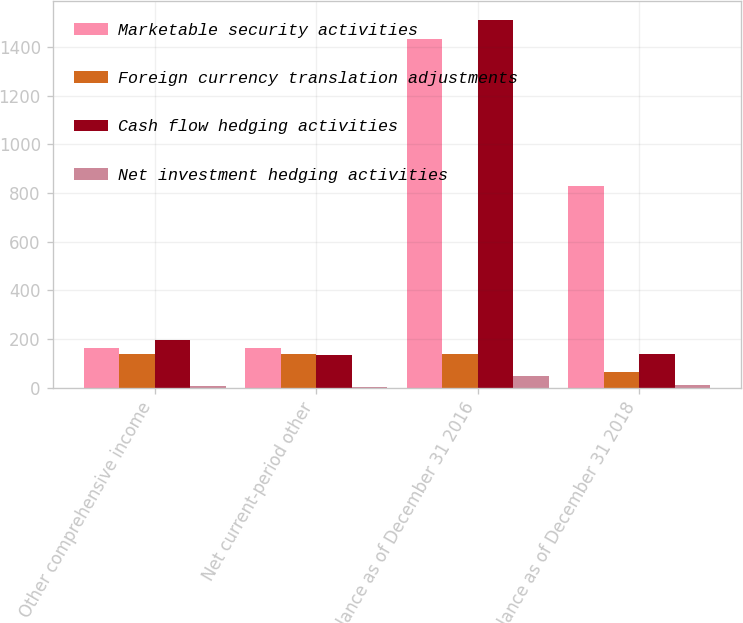Convert chart. <chart><loc_0><loc_0><loc_500><loc_500><stacked_bar_chart><ecel><fcel>Other comprehensive income<fcel>Net current-period other<fcel>Balance as of December 31 2016<fcel>Balance as of December 31 2018<nl><fcel>Marketable security activities<fcel>165<fcel>165<fcel>1435<fcel>830<nl><fcel>Foreign currency translation adjustments<fcel>140<fcel>140<fcel>140<fcel>65<nl><fcel>Cash flow hedging activities<fcel>194<fcel>135<fcel>1513<fcel>140<nl><fcel>Net investment hedging activities<fcel>7<fcel>1<fcel>46<fcel>10<nl></chart> 